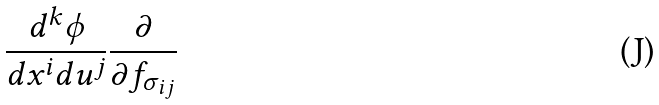Convert formula to latex. <formula><loc_0><loc_0><loc_500><loc_500>\frac { d ^ { k } \phi } { d x ^ { i } d u ^ { j } } \frac { \partial } { \partial f _ { \sigma _ { i j } } }</formula> 